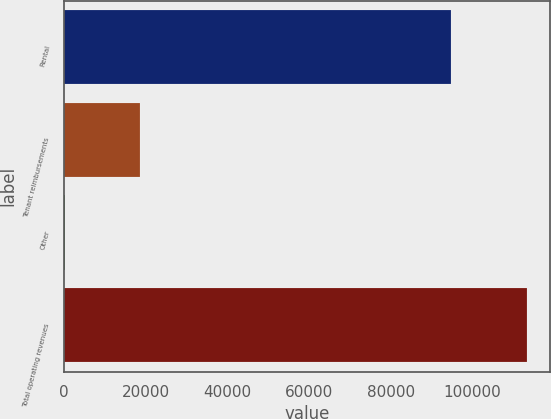<chart> <loc_0><loc_0><loc_500><loc_500><bar_chart><fcel>Rental<fcel>Tenant reimbursements<fcel>Other<fcel>Total operating revenues<nl><fcel>94711<fcel>18479<fcel>168<fcel>113358<nl></chart> 